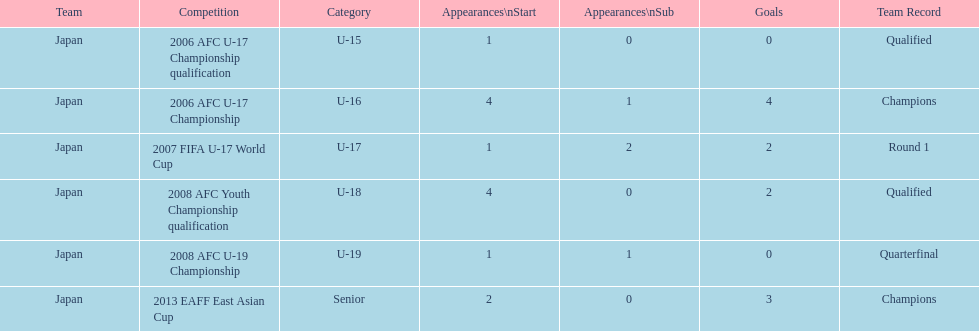In which tournament did japan have more starting appearances: the 2013 eaff east asian cup or the 2007 fifa u-17 world cup? 2013 EAFF East Asian Cup. Could you parse the entire table as a dict? {'header': ['Team', 'Competition', 'Category', 'Appearances\\nStart', 'Appearances\\nSub', 'Goals', 'Team Record'], 'rows': [['Japan', '2006 AFC U-17 Championship qualification', 'U-15', '1', '0', '0', 'Qualified'], ['Japan', '2006 AFC U-17 Championship', 'U-16', '4', '1', '4', 'Champions'], ['Japan', '2007 FIFA U-17 World Cup', 'U-17', '1', '2', '2', 'Round 1'], ['Japan', '2008 AFC Youth Championship qualification', 'U-18', '4', '0', '2', 'Qualified'], ['Japan', '2008 AFC U-19 Championship', 'U-19', '1', '1', '0', 'Quarterfinal'], ['Japan', '2013 EAFF East Asian Cup', 'Senior', '2', '0', '3', 'Champions']]} 